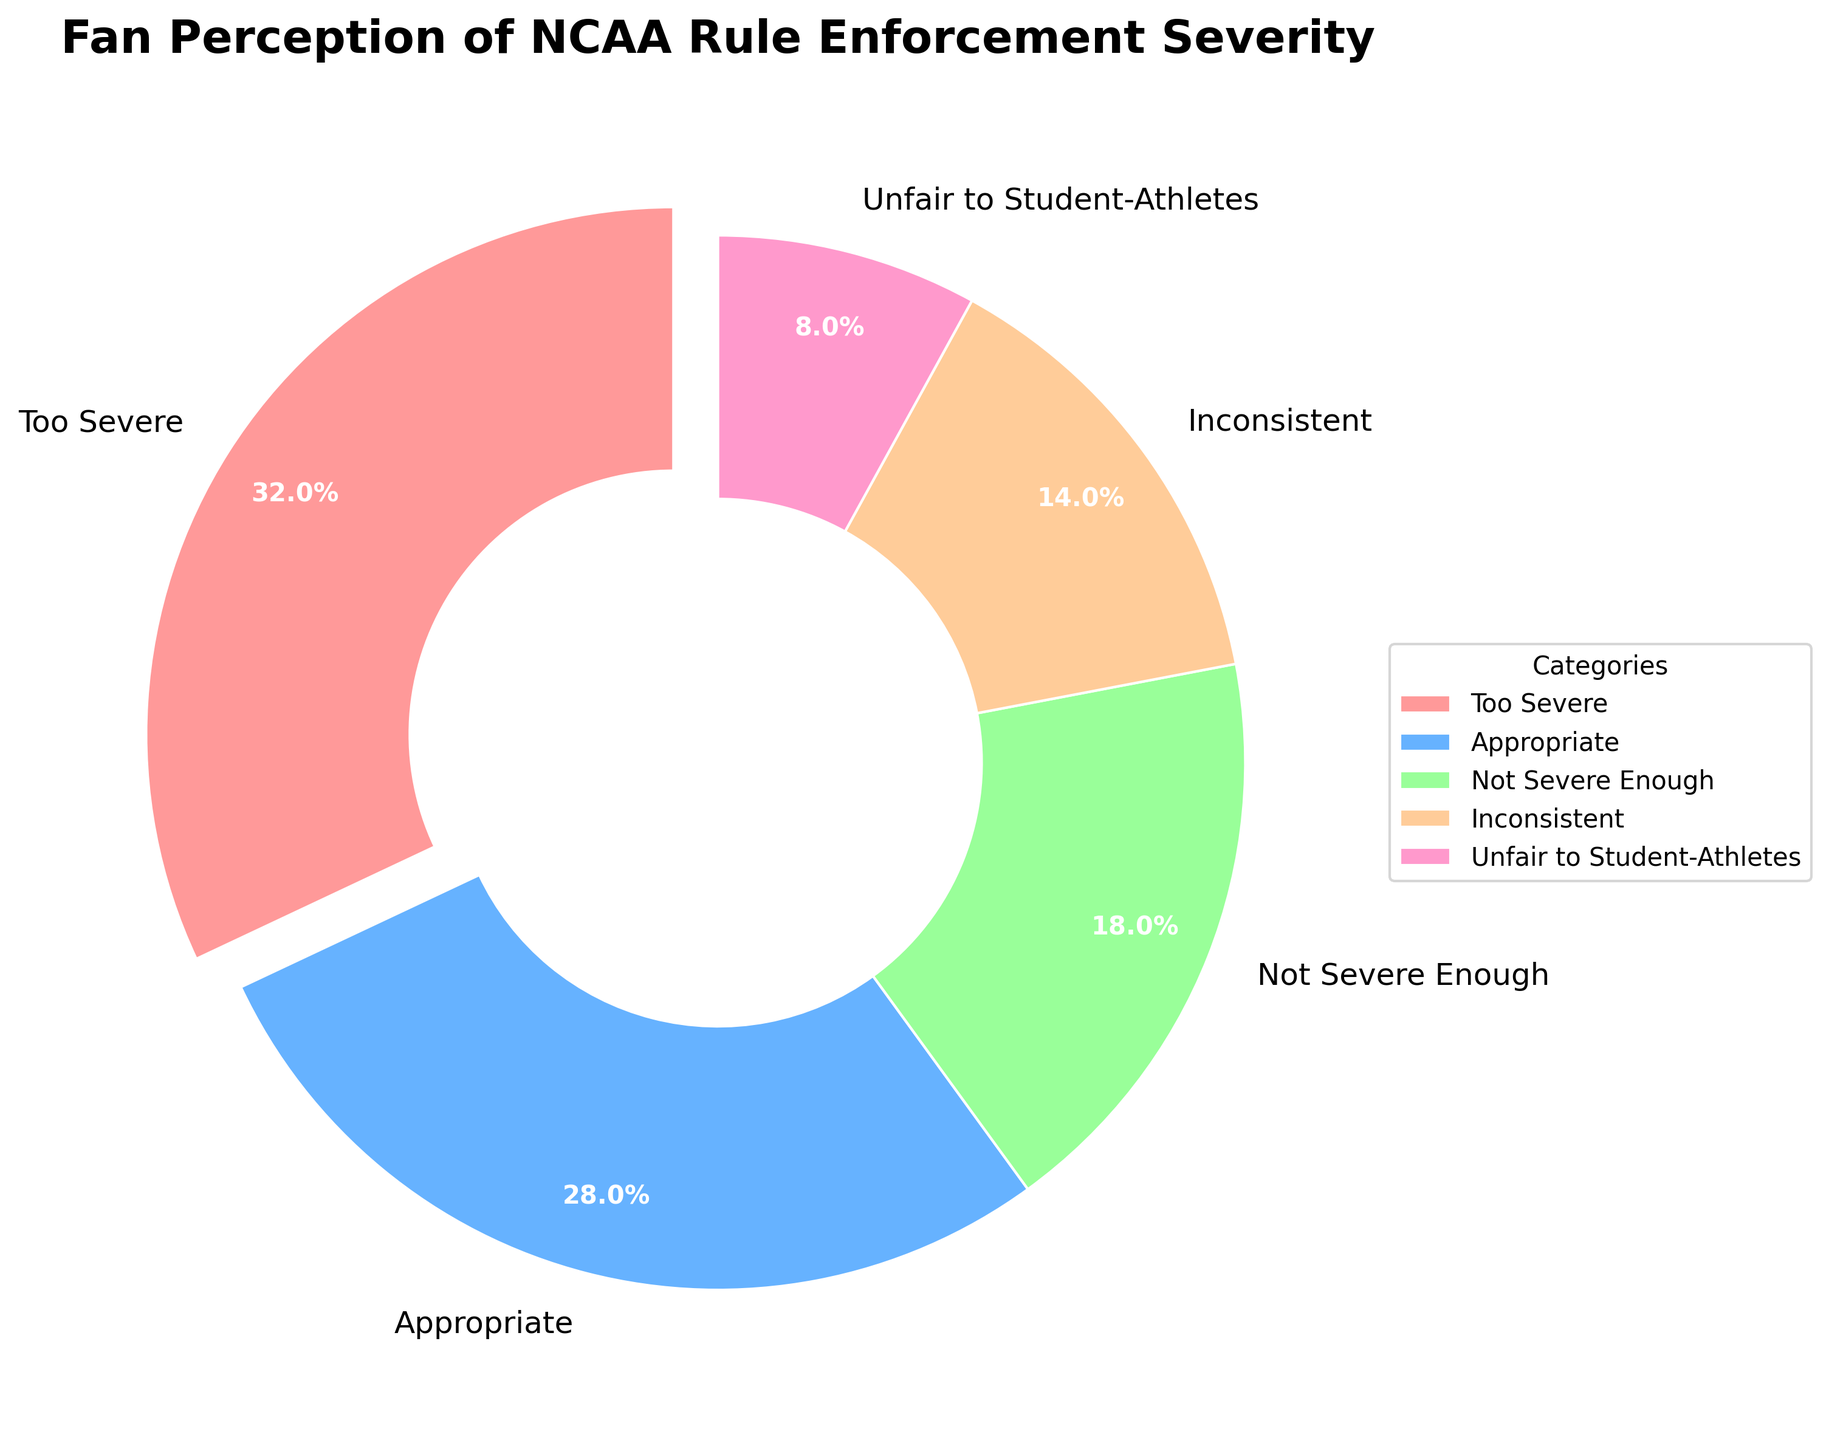What's the largest category in the pie chart? The largest category in the pie chart is visually identifiable by its relative size compared to the others. In this case, the "Too Severe" category takes up the most space.
Answer: Too Severe Which category has the smallest percentage? The smallest segment can be visually identified as the smallest slice in the pie chart. Here, "Unfair to Student-Athletes" appears to be the smallest.
Answer: Unfair to Student-Athletes What two categories combined make up more than 50%? Adding the percentages of each category, "Too Severe" (32%) and "Appropriate" (28%) together yield a sum of 60%, which is more than 50%.
Answer: Too Severe and Appropriate How does the "Not Severe Enough" category compare to the "Inconsistent" category? By comparing the visual sizes, we can see that "Not Severe Enough" (18%) is larger than "Inconsistent" (14%).
Answer: Not Severe Enough is larger What is the difference between the largest and smallest categories? The largest category is "Too Severe" at 32%, and the smallest is "Unfair to Student-Athletes" at 8%. The difference is 32% - 8% = 24%.
Answer: 24% Which category is represented by the color red? By observing the pie chart's colors, the segment labeled "Too Severe" is noticeably red.
Answer: Too Severe List all categories that account for less than 20% of fan perception. Visually identifying segments each less than 20%, "Not Severe Enough" (18%), "Inconsistent" (14%), and "Unfair to Student-Athletes" (8%) are all below 20%.
Answer: Not Severe Enough, Inconsistent, Unfair to Student-Athletes Which categories in the pie chart have a difference of exactly 10%? Comparing the given percentages, "Too Severe" (32%) and "Appropriate" (28%) have a difference of 4%, but "Appropriate" (28%) and "Not Severe Enough" (18%) have exactly a 10% difference.
Answer: Appropriate and Not Severe Enough What is the combined percentage of the categories labeled as "Inconsistent" and "Unfair to Student-Athletes"? Adding the percentages for "Inconsistent" (14%) and "Unfair to Student-Athletes" (8%) results in a total of 22%.
Answer: 22% Given the colors presented in the chart, which color represents the category labeled "Appropriate"? Observing the pie chart's color scheme, the color associated with the "Appropriate" label is blue.
Answer: Blue 